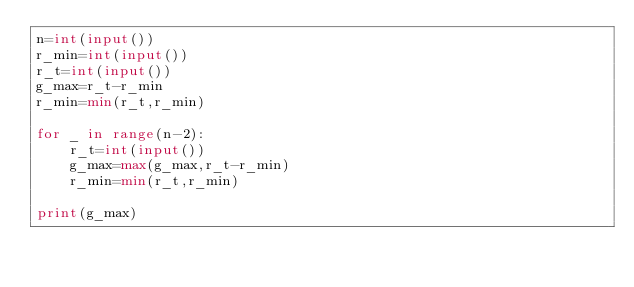Convert code to text. <code><loc_0><loc_0><loc_500><loc_500><_Python_>n=int(input())
r_min=int(input())
r_t=int(input())
g_max=r_t-r_min
r_min=min(r_t,r_min)

for _ in range(n-2):
    r_t=int(input())
    g_max=max(g_max,r_t-r_min)
    r_min=min(r_t,r_min)

print(g_max)
</code> 